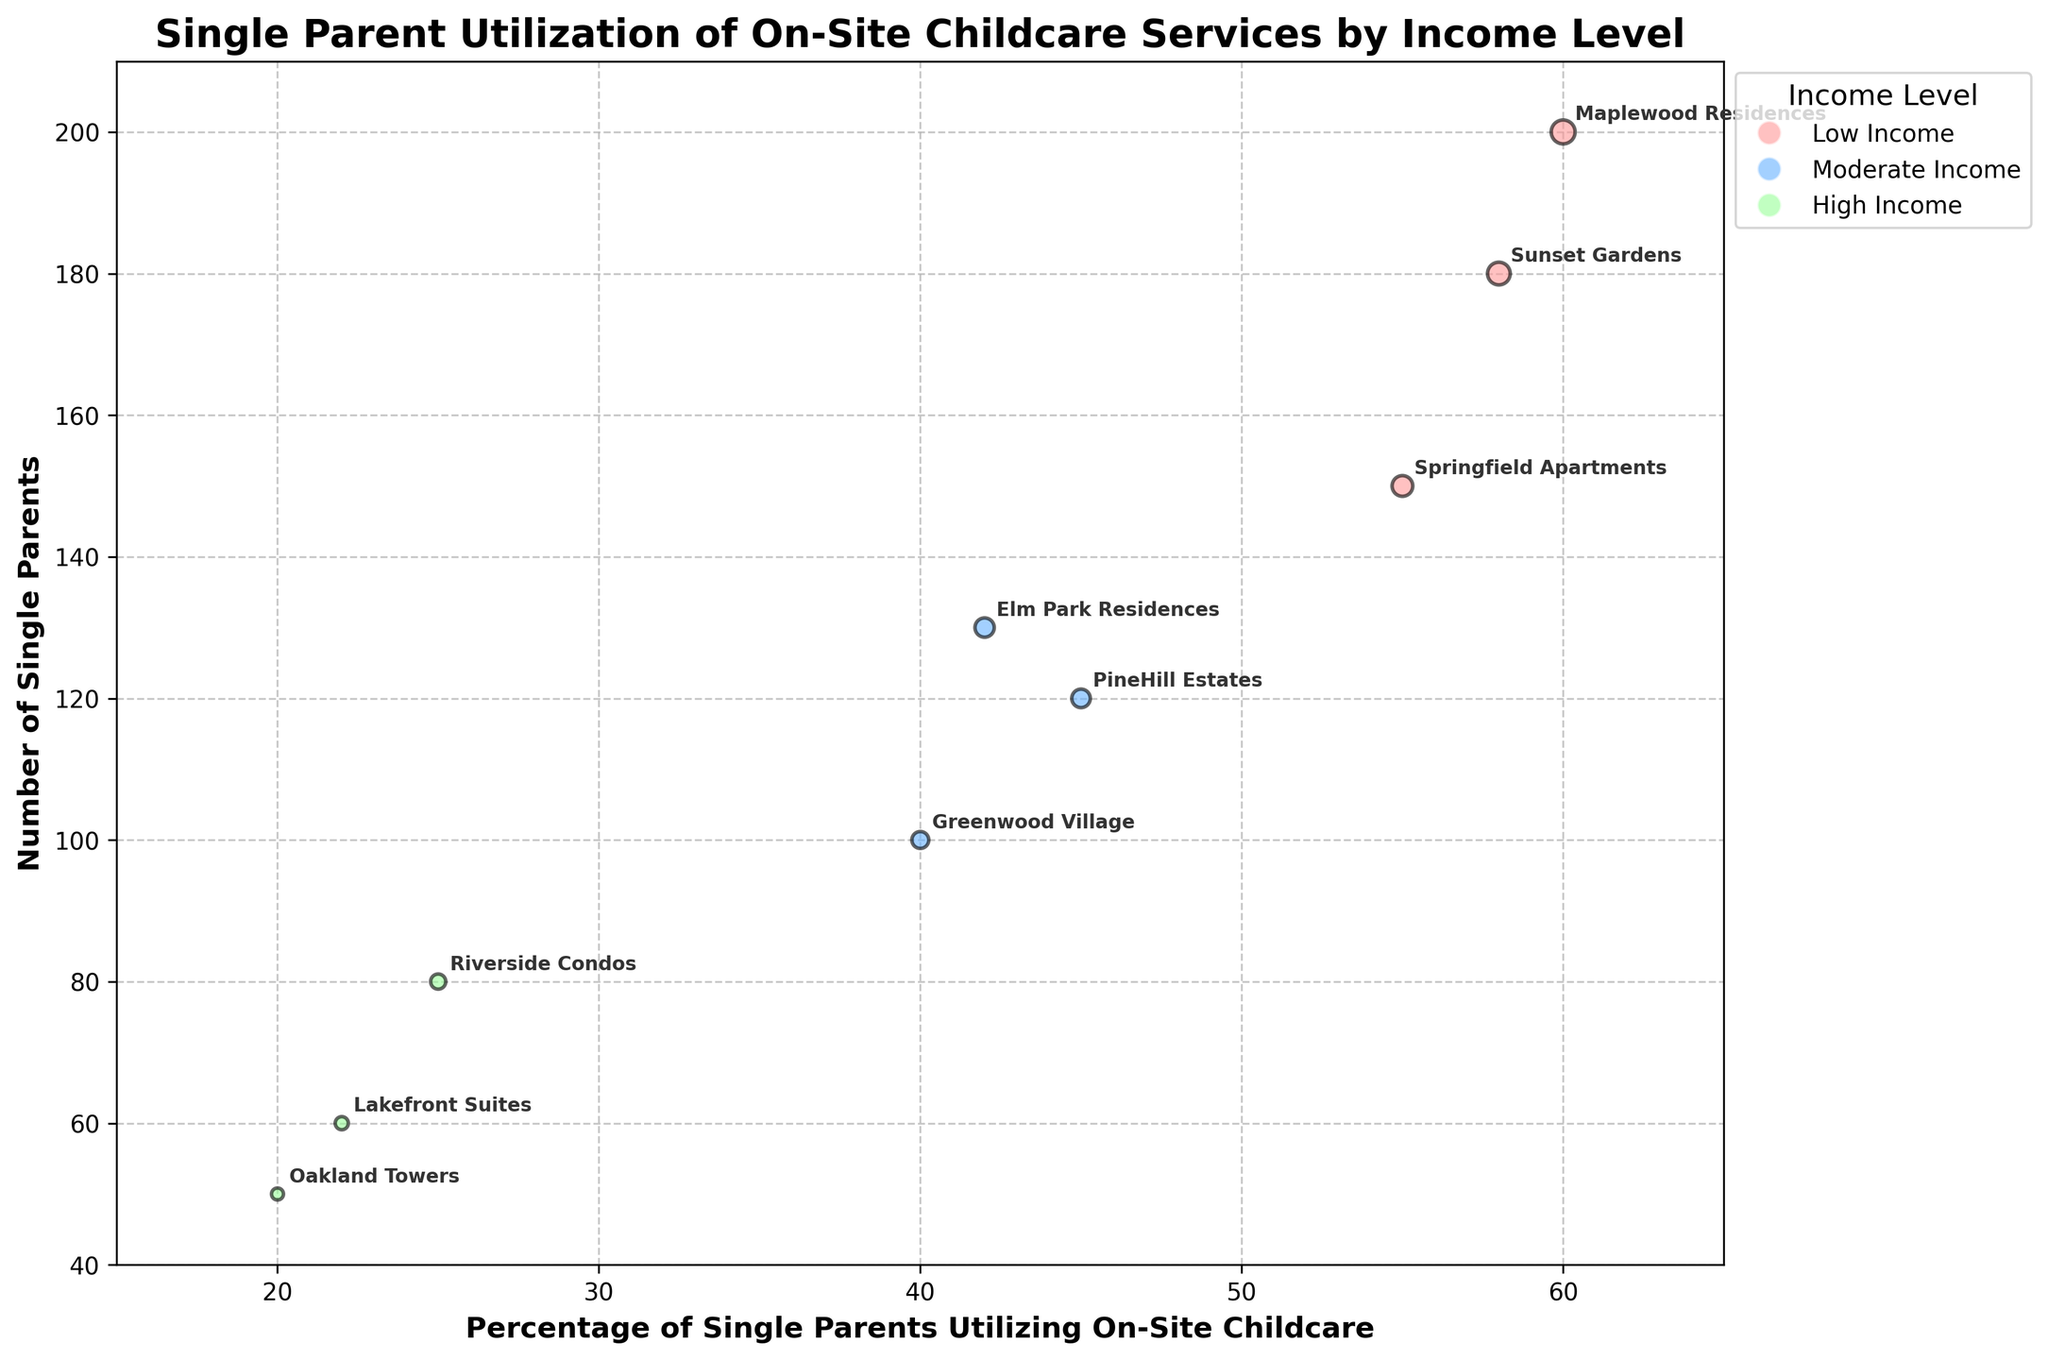What is the title of the figure? The title of the figure is usually placed at the top and is in a bold font. In this plot, it reads "Single Parent Utilization of On-Site Childcare Services by Income Level".
Answer: Single Parent Utilization of On-Site Childcare Services by Income Level What is the color used for the 'Low Income' bubbles? The legend typically indicates the color choices for different income levels. According to the legend, 'Low Income' bubbles are represented in a reddish color.
Answer: Red Which location has the highest number of single parents? By observing the y-axis, which represents the number of single parents, search for the bubble located highest on the y-axis. The highest point corresponds to 'Sunset Gardens'.
Answer: Sunset Gardens What is the percentage of single parents utilizing on-site childcare at Lakefront Suites? Locate the bubble labeled 'Lakefront Suites' and check its position on the x-axis, which shows the percentage of utilization. The percentage is approximately 22%.
Answer: 22% How many locations are plotted in the figure? Count all the different annotated locations within the bubble chart. The figure shows a total of 9 different locations.
Answer: 9 Which income level has the largest mean value of single parent utilization of on-site childcare services? Calculate the average utilization percentage for each income level:
- Low Income: (55 + 60 + 58) / 3 = 57.67%
- Moderate Income: (40 + 45 + 42) / 3 = 42.33%
- High Income: (20 + 25 + 22) / 3 = 22.33%
The highest mean value corresponds to Low Income.
Answer: Low Income Which location has the smallest bubble size? The bubble size corresponds to the 'Number of Single Parents', so look for the smallest bubble in the chart. 'Oakland Towers' has the smallest bubble.
Answer: Oakland Towers Which income level generally has lower percentages of single parents utilizing on-site childcare services? Compare the x-axis positions of the bubbles across different income levels. Bubbles representing 'High Income' are generally positioned lower on the x-axis, indicating lower percentages.
Answer: High Income Between 'Maplewood Residences' and 'Riverside Condos', which one has a higher percentage of single parents utilizing the on-site childcare services? Check the x-axis positions of the bubbles labeled 'Maplewood Residences' and 'Riverside Condos'. 'Maplewood Residences' is at 60%, which is higher than 'Riverside Condos' at 25%.
Answer: Maplewood Residences Is there any location in the 'Moderate Income' group that has more than 120 single parents? Observe the y-axis positions for the 'Moderate Income' bubbles, checking their annotation labels. 'Elm Park Residences' is the only one with more than 120 single parents (specifically, it has 130).
Answer: Elm Park Residences 